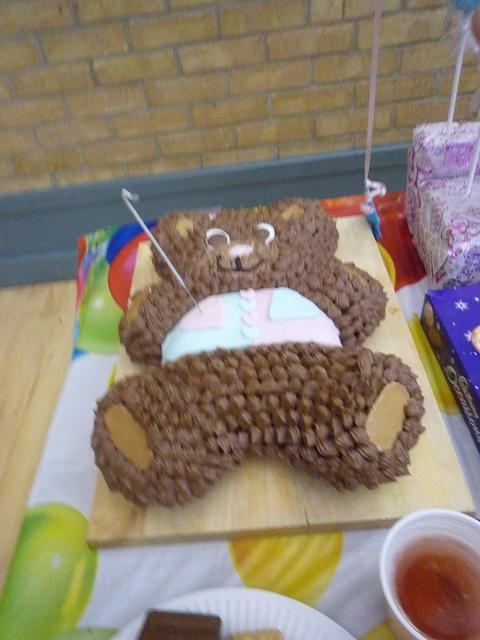Is the statement "The teddy bear is on top of the cake." accurate regarding the image?
Answer yes or no. No. Is this affirmation: "The cake is on top of the teddy bear." correct?
Answer yes or no. No. Does the image validate the caption "The teddy bear is perpendicular to the cake."?
Answer yes or no. No. Does the image validate the caption "The cake consists of the teddy bear."?
Answer yes or no. Yes. 